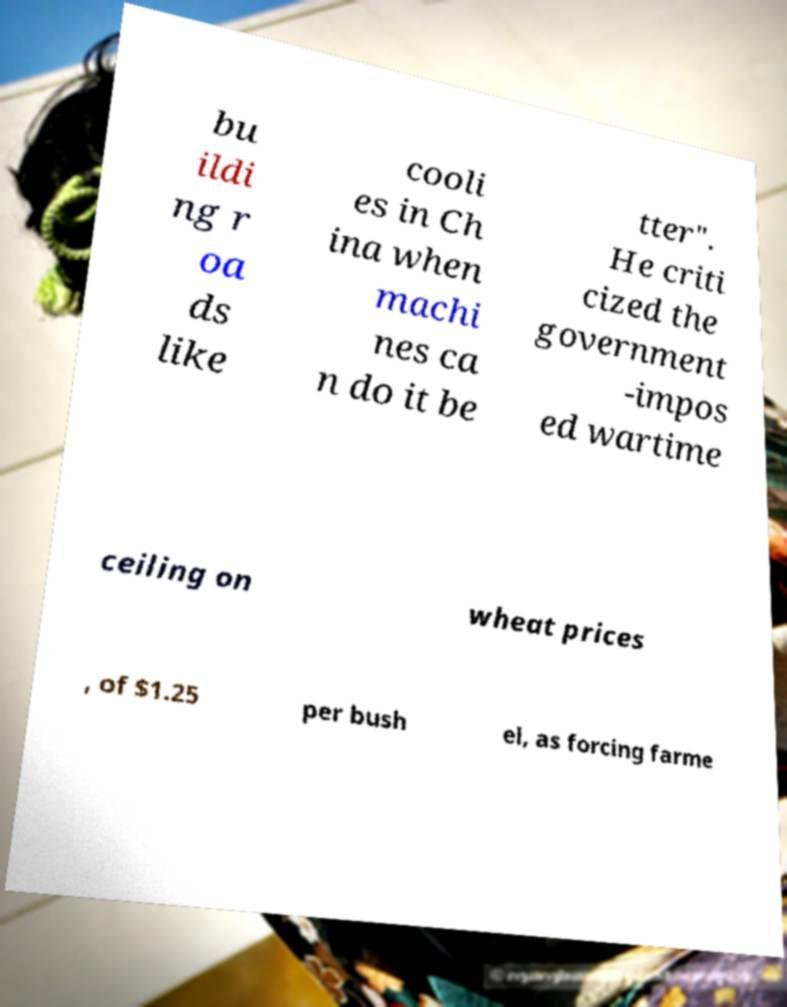Can you read and provide the text displayed in the image?This photo seems to have some interesting text. Can you extract and type it out for me? bu ildi ng r oa ds like cooli es in Ch ina when machi nes ca n do it be tter". He criti cized the government -impos ed wartime ceiling on wheat prices , of $1.25 per bush el, as forcing farme 